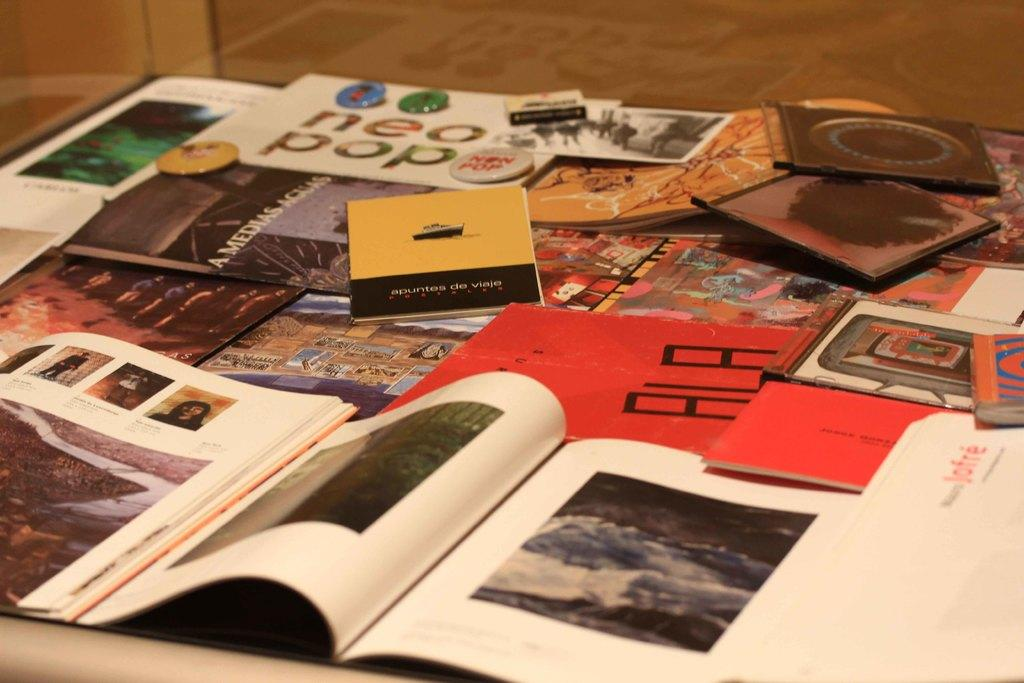<image>
Write a terse but informative summary of the picture. A magazine that says Neo Pop is on a cluttered table. 